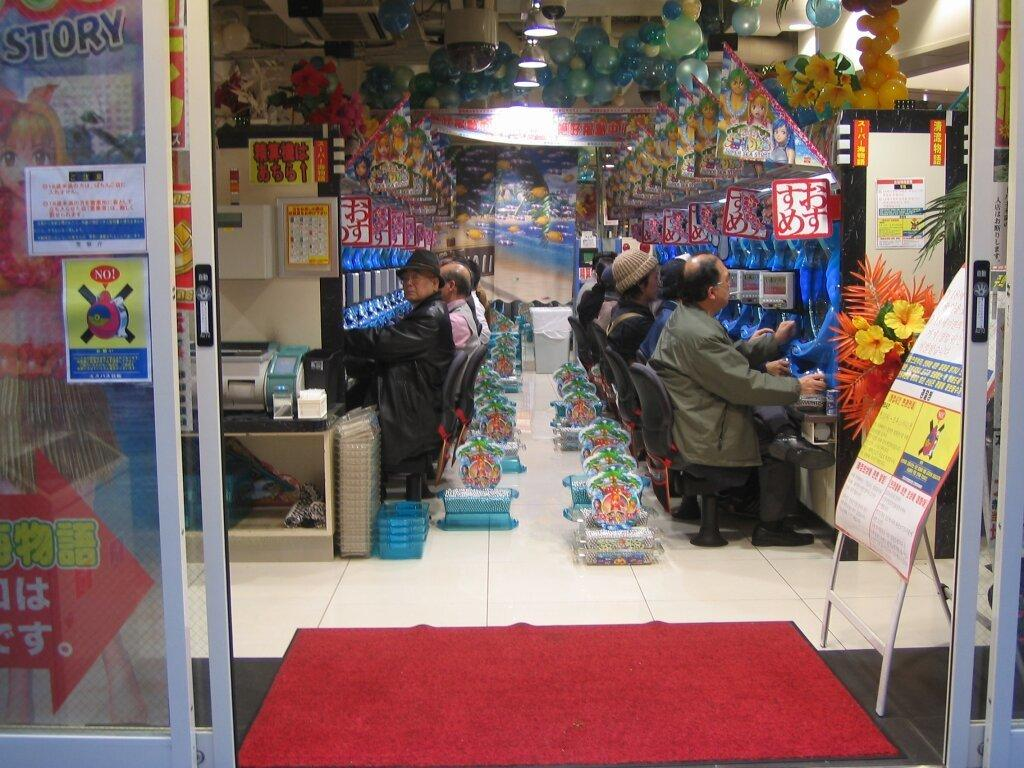<image>
Offer a succinct explanation of the picture presented. A sign to the left of the door warns to not do something. 